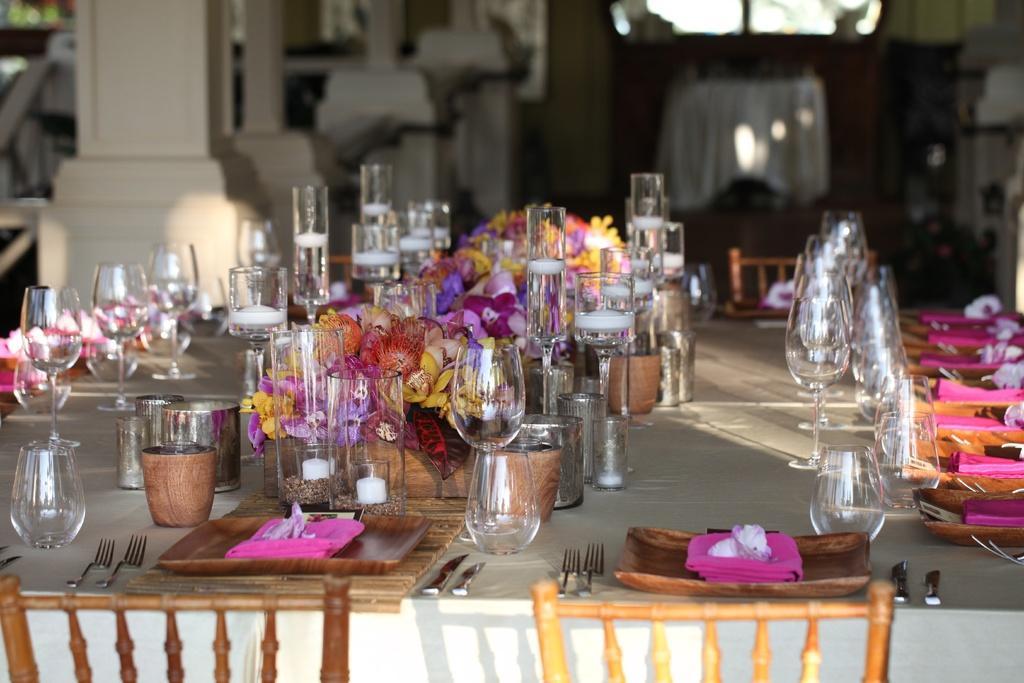Please provide a concise description of this image. In the image there is dining table on which are plates,forks,wine glasses,bowls,bowls,flowers in middle and chairs in front of the table,this looks like a dining room. 